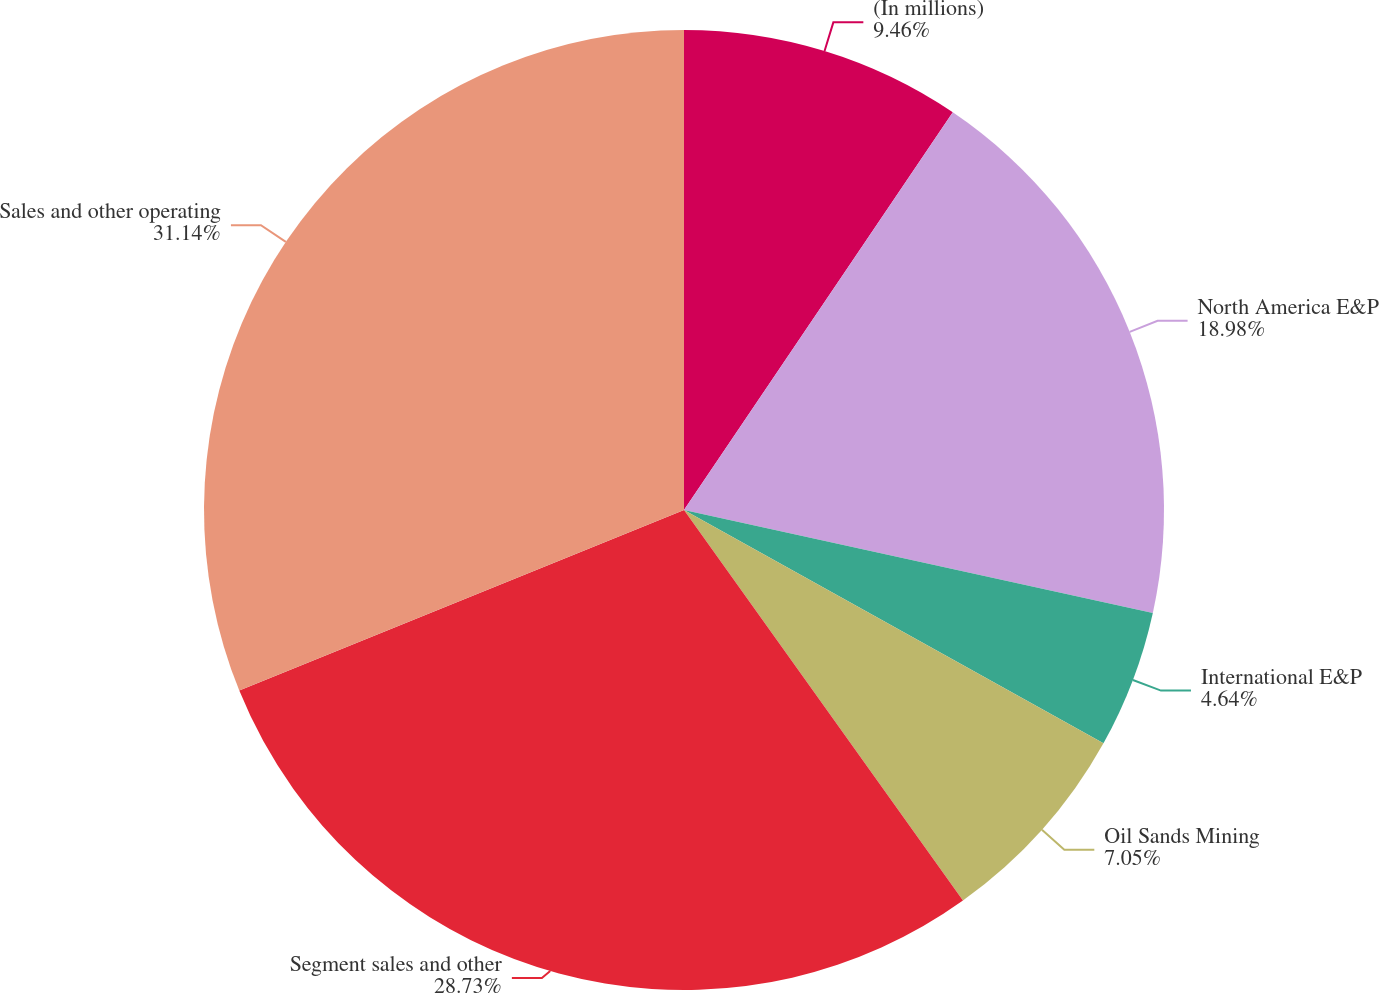<chart> <loc_0><loc_0><loc_500><loc_500><pie_chart><fcel>(In millions)<fcel>North America E&P<fcel>International E&P<fcel>Oil Sands Mining<fcel>Segment sales and other<fcel>Sales and other operating<nl><fcel>9.46%<fcel>18.98%<fcel>4.64%<fcel>7.05%<fcel>28.73%<fcel>31.14%<nl></chart> 